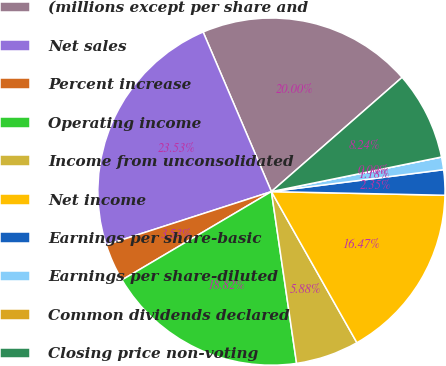Convert chart to OTSL. <chart><loc_0><loc_0><loc_500><loc_500><pie_chart><fcel>(millions except per share and<fcel>Net sales<fcel>Percent increase<fcel>Operating income<fcel>Income from unconsolidated<fcel>Net income<fcel>Earnings per share-basic<fcel>Earnings per share-diluted<fcel>Common dividends declared<fcel>Closing price non-voting<nl><fcel>20.0%<fcel>23.53%<fcel>3.53%<fcel>18.82%<fcel>5.88%<fcel>16.47%<fcel>2.35%<fcel>1.18%<fcel>0.0%<fcel>8.24%<nl></chart> 